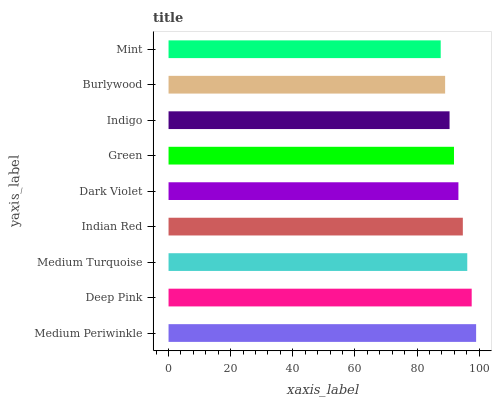Is Mint the minimum?
Answer yes or no. Yes. Is Medium Periwinkle the maximum?
Answer yes or no. Yes. Is Deep Pink the minimum?
Answer yes or no. No. Is Deep Pink the maximum?
Answer yes or no. No. Is Medium Periwinkle greater than Deep Pink?
Answer yes or no. Yes. Is Deep Pink less than Medium Periwinkle?
Answer yes or no. Yes. Is Deep Pink greater than Medium Periwinkle?
Answer yes or no. No. Is Medium Periwinkle less than Deep Pink?
Answer yes or no. No. Is Dark Violet the high median?
Answer yes or no. Yes. Is Dark Violet the low median?
Answer yes or no. Yes. Is Deep Pink the high median?
Answer yes or no. No. Is Mint the low median?
Answer yes or no. No. 